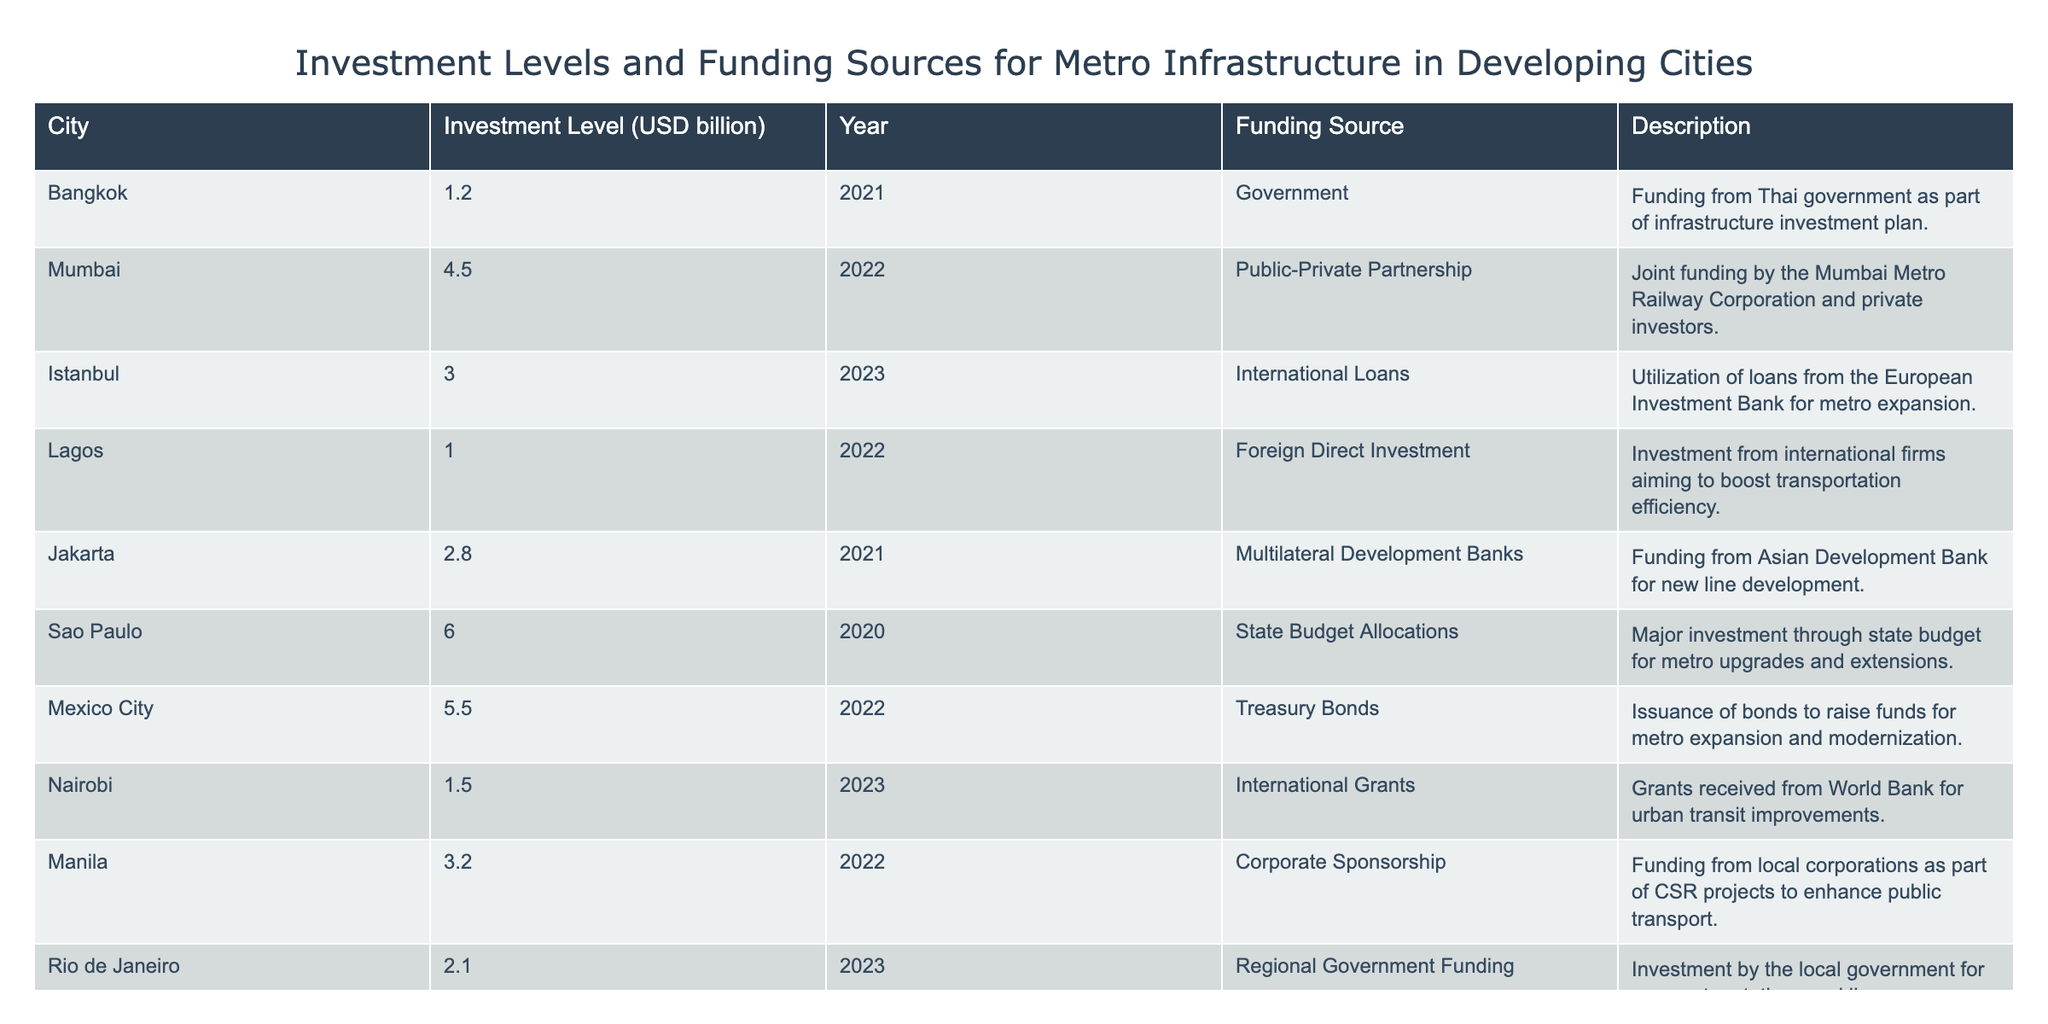What city received funding through international loans for metro expansion? The table indicates that Istanbul utilized international loans from the European Investment Bank for metro expansion.
Answer: Istanbul What is the total investment level for metro infrastructure from the cities listed? To calculate the total investment, sum all the values: 1.2 + 4.5 + 3.0 + 1.0 + 2.8 + 6.0 + 5.5 + 1.5 + 3.2 + 2.1 = 27.8 billion USD.
Answer: 27.8 billion USD Did any city rely solely on foreign direct investment for its metro funding? The table shows that Lagos primarily relied on foreign direct investment to boost transportation efficiency, indicating yes.
Answer: Yes Which city has the highest investment level and what is its funding source? The highest investment level is from Sao Paulo, which is 6.0 billion USD, funded through state budget allocations.
Answer: Sao Paulo, State Budget Allocations What is the average investment level from all listed cities? To find the average, sum the investments (27.8 billion USD) and divide by the number of cities (10): 27.8 / 10 = 2.78 billion USD.
Answer: 2.78 billion USD Is there a city that received international grants for its metro infrastructure? The table confirms that Nairobi received international grants from the World Bank for urban transit improvements, indicating yes.
Answer: Yes Which city had the lowest investment level and what was the funding source? The lowest investment level is from Lagos at 1.0 billion USD, funded by foreign direct investment.
Answer: Lagos, Foreign Direct Investment How many cities had investments greater than 3 billion USD? The cities with investments greater than 3 billion USD are Mumbai, Istanbul, Sao Paulo, and Mexico City. That makes it a total of four cities.
Answer: 4 Was there corporate sponsorship mentioned in the funding sources? Yes, the table shows that Manila received funding from local corporations as part of corporate social responsibility (CSR) projects.
Answer: Yes 